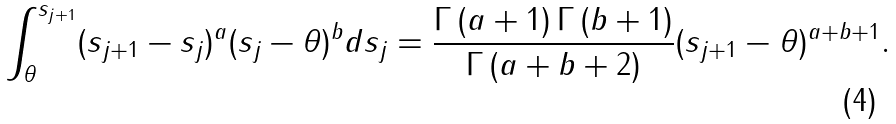<formula> <loc_0><loc_0><loc_500><loc_500>\int _ { \theta } ^ { s _ { j + 1 } } ( s _ { j + 1 } - s _ { j } ) ^ { a } ( s _ { j } - \theta ) ^ { b } d s _ { j } = \frac { \Gamma \left ( a + 1 \right ) \Gamma \left ( b + 1 \right ) } { \Gamma \left ( a + b + 2 \right ) } ( s _ { j + 1 } - \theta ) ^ { a + b + 1 } .</formula> 